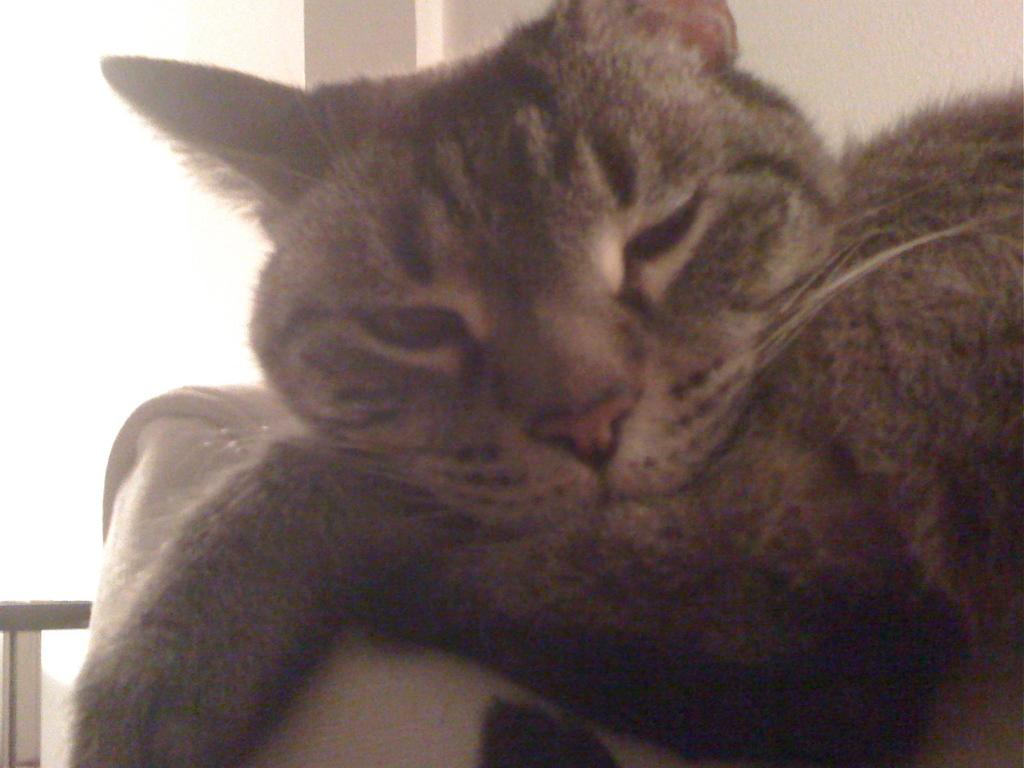What type of animal is in the image? There is a cat in the image. What is visible at the top of the image? There is a wall visible at the top of the image. How many nuts are being cracked by the cat in the image? There are no nuts present in the image; it features a cat and a wall. 